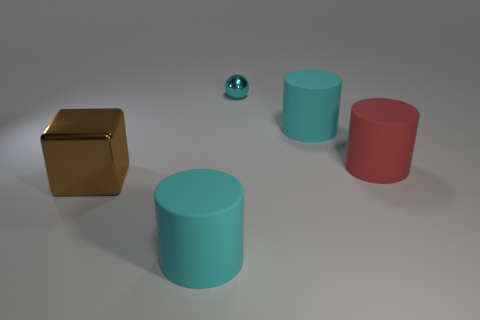Add 4 matte cylinders. How many objects exist? 9 Subtract all cylinders. How many objects are left? 2 Subtract 0 brown cylinders. How many objects are left? 5 Subtract all large cyan matte things. Subtract all matte objects. How many objects are left? 0 Add 2 red objects. How many red objects are left? 3 Add 1 small metallic objects. How many small metallic objects exist? 2 